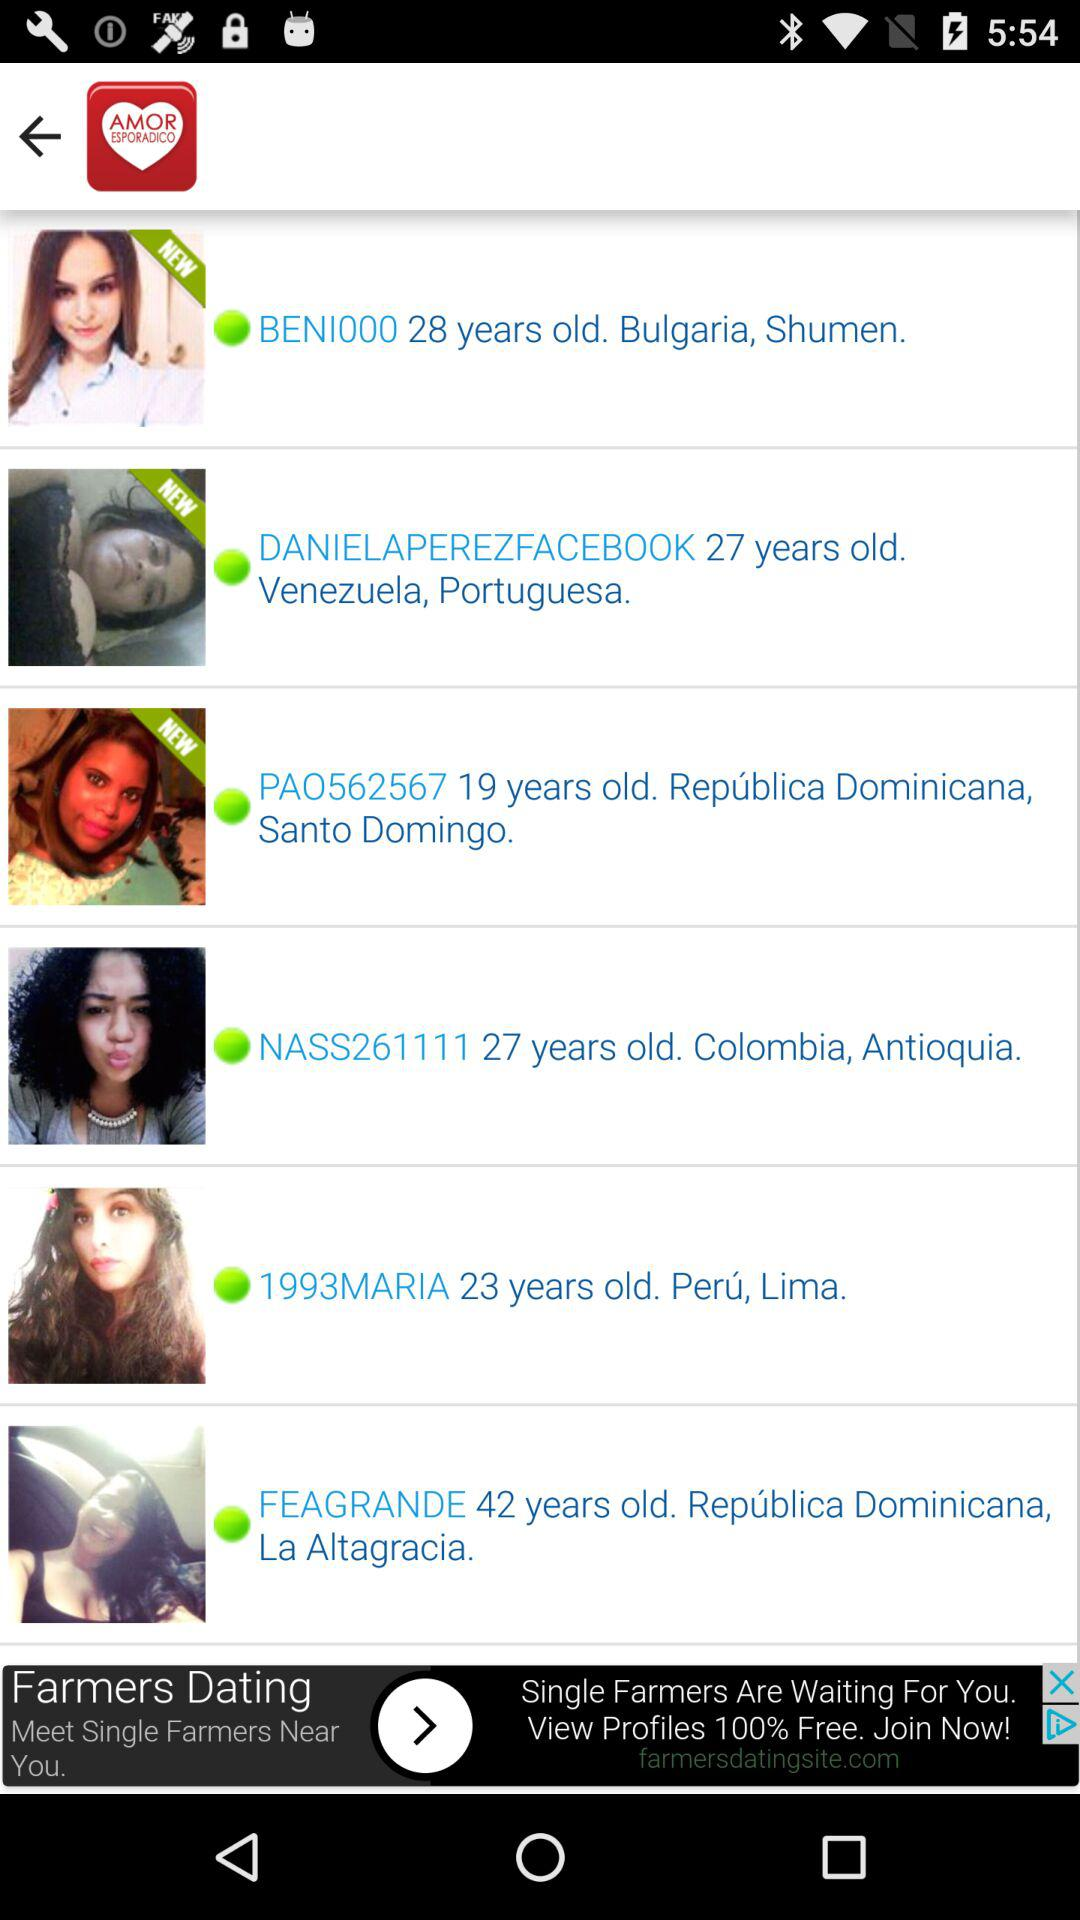What is the current location of "NASS261111"? The current location is Antioquia, Colombia. 